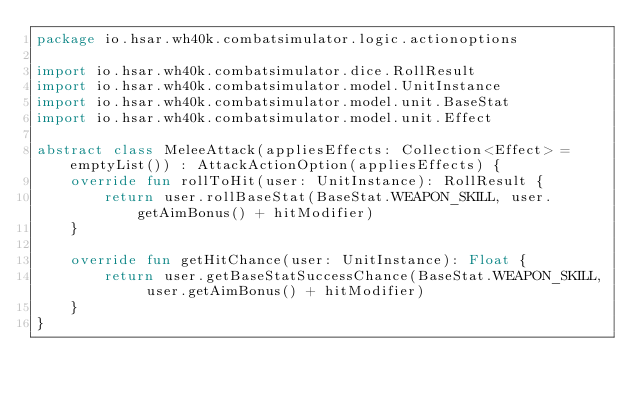Convert code to text. <code><loc_0><loc_0><loc_500><loc_500><_Kotlin_>package io.hsar.wh40k.combatsimulator.logic.actionoptions

import io.hsar.wh40k.combatsimulator.dice.RollResult
import io.hsar.wh40k.combatsimulator.model.UnitInstance
import io.hsar.wh40k.combatsimulator.model.unit.BaseStat
import io.hsar.wh40k.combatsimulator.model.unit.Effect

abstract class MeleeAttack(appliesEffects: Collection<Effect> = emptyList()) : AttackActionOption(appliesEffects) {
    override fun rollToHit(user: UnitInstance): RollResult {
        return user.rollBaseStat(BaseStat.WEAPON_SKILL, user.getAimBonus() + hitModifier)
    }

    override fun getHitChance(user: UnitInstance): Float {
        return user.getBaseStatSuccessChance(BaseStat.WEAPON_SKILL, user.getAimBonus() + hitModifier)
    }
}</code> 